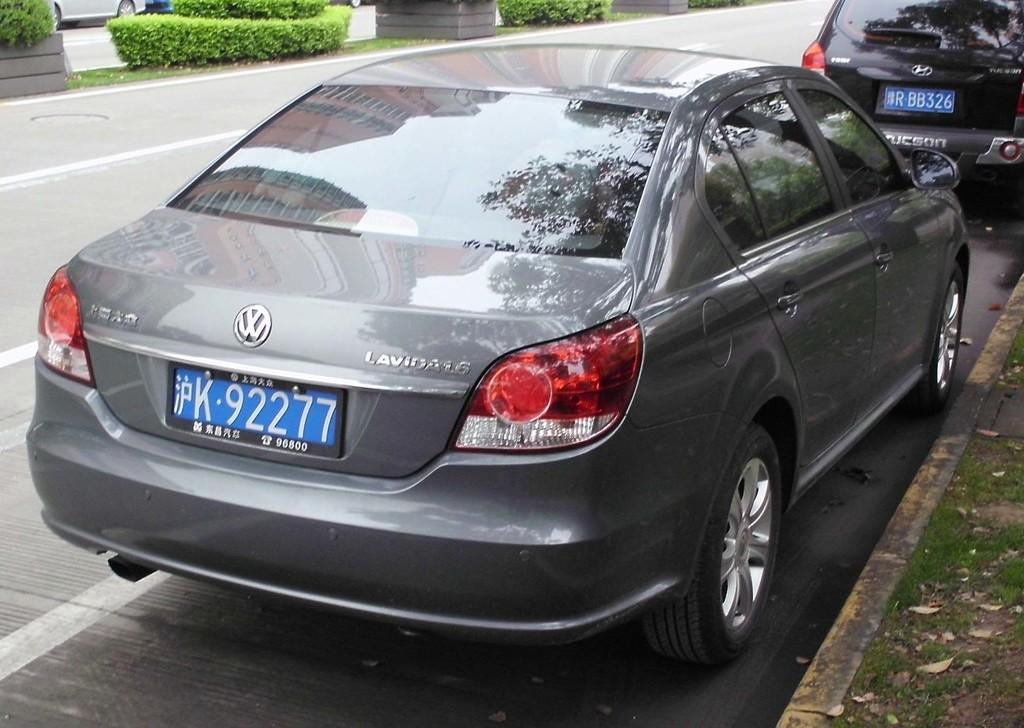<image>
Give a short and clear explanation of the subsequent image. A grey Volkswagon with a blue tag that reads K-92277. 